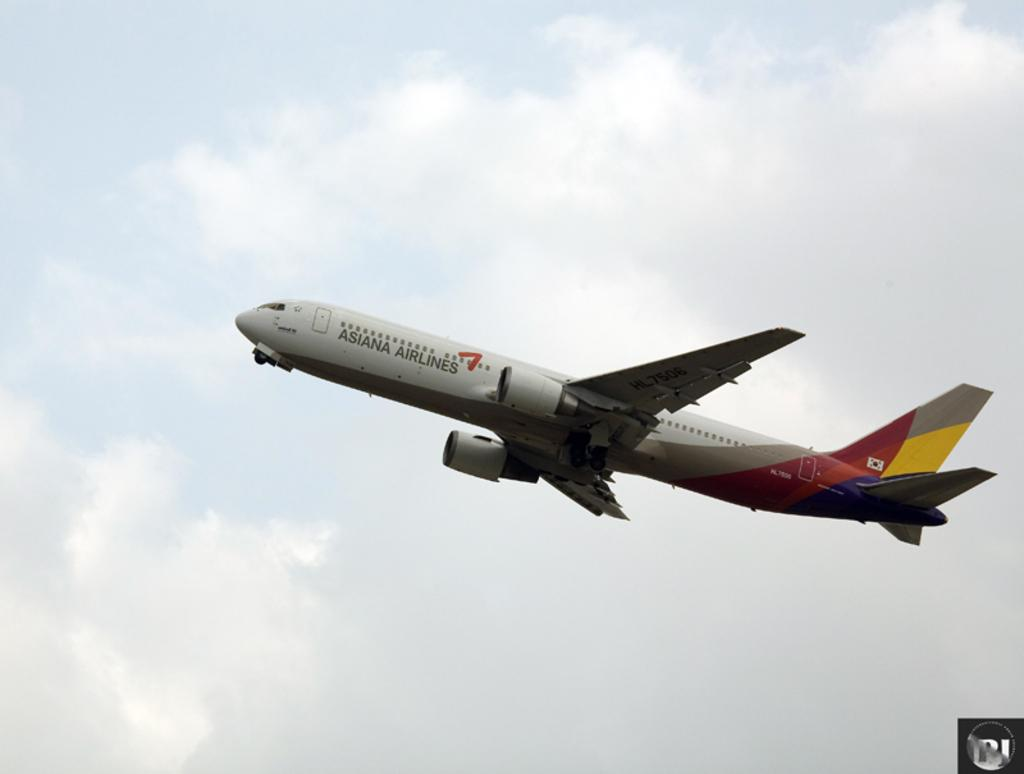What is the main subject of the image? The main subject of the image is an aeroplane. What is the aeroplane doing in the image? The aeroplane is flying in the sky. What can be seen in the background of the image? There are clouds in the sky in the background of the image. What type of linen is being used to clean the aeroplane in the image? There is no linen or cleaning activity depicted in the image; it simply shows an aeroplane flying in the sky. 